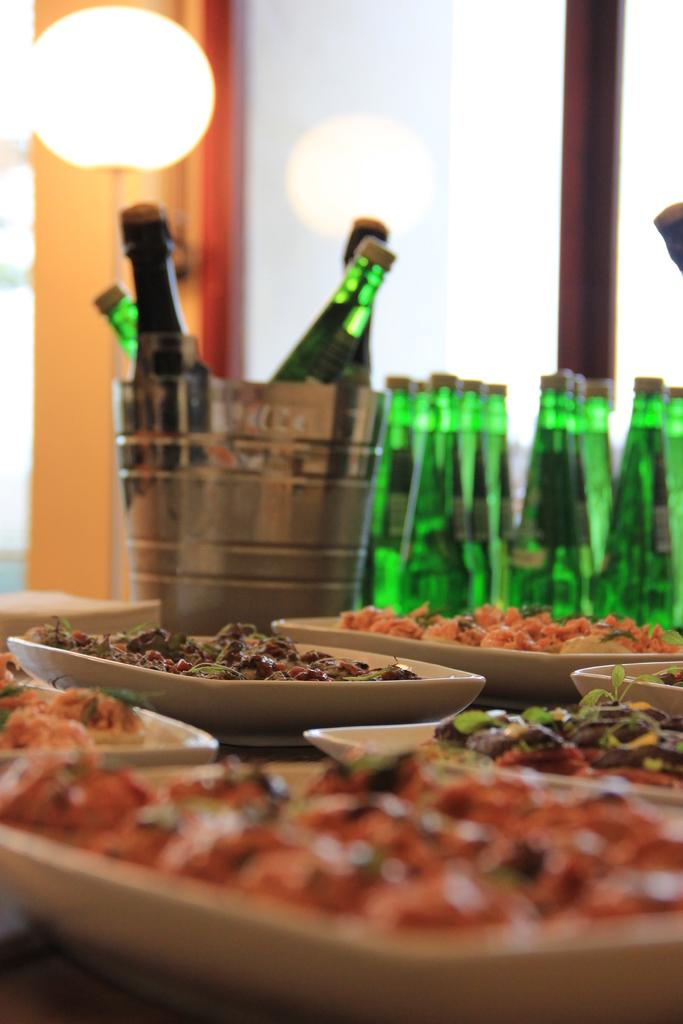What objects are arranged in a group in the image? There is a group of bottles in the image. What else can be seen on the table in the image? There are plates and food on the table in the image. Can you describe the lighting in the image? There is a light in the background of the image. What type of steam is coming from the dinner in the image? There is no dinner or steam present in the image; it features a group of bottles, plates, food, and a light. 